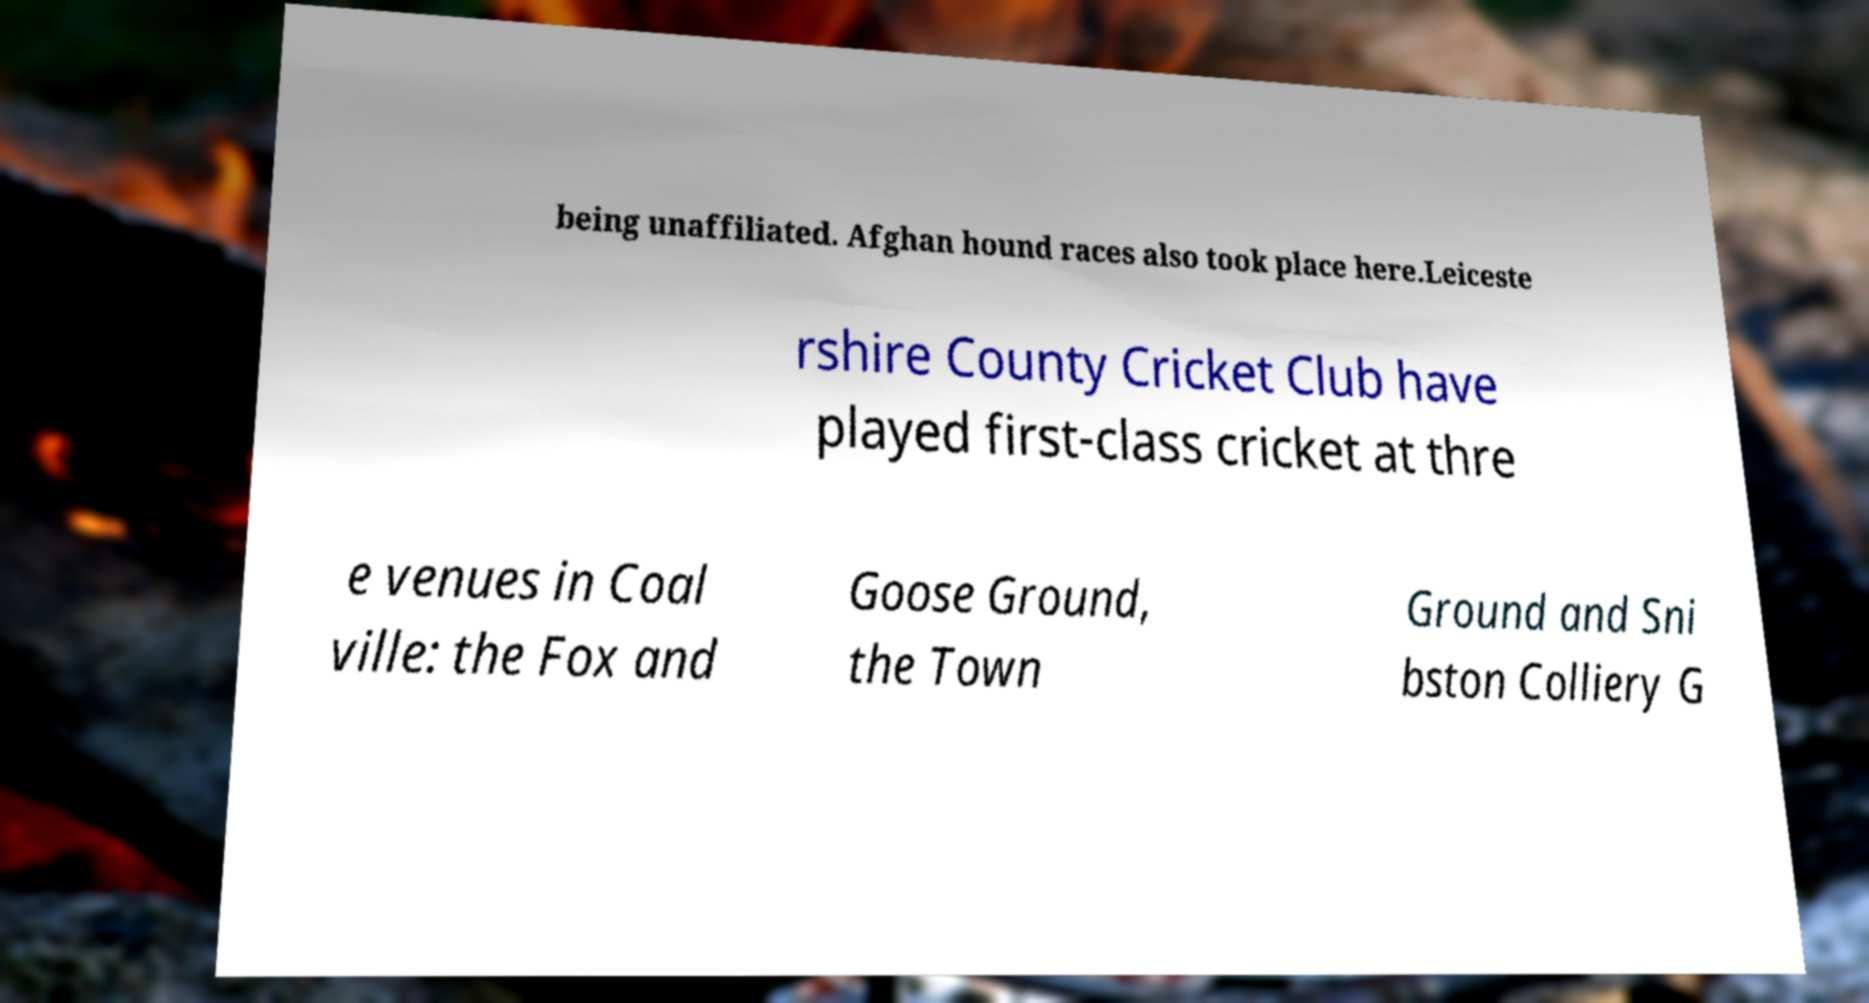I need the written content from this picture converted into text. Can you do that? being unaffiliated. Afghan hound races also took place here.Leiceste rshire County Cricket Club have played first-class cricket at thre e venues in Coal ville: the Fox and Goose Ground, the Town Ground and Sni bston Colliery G 